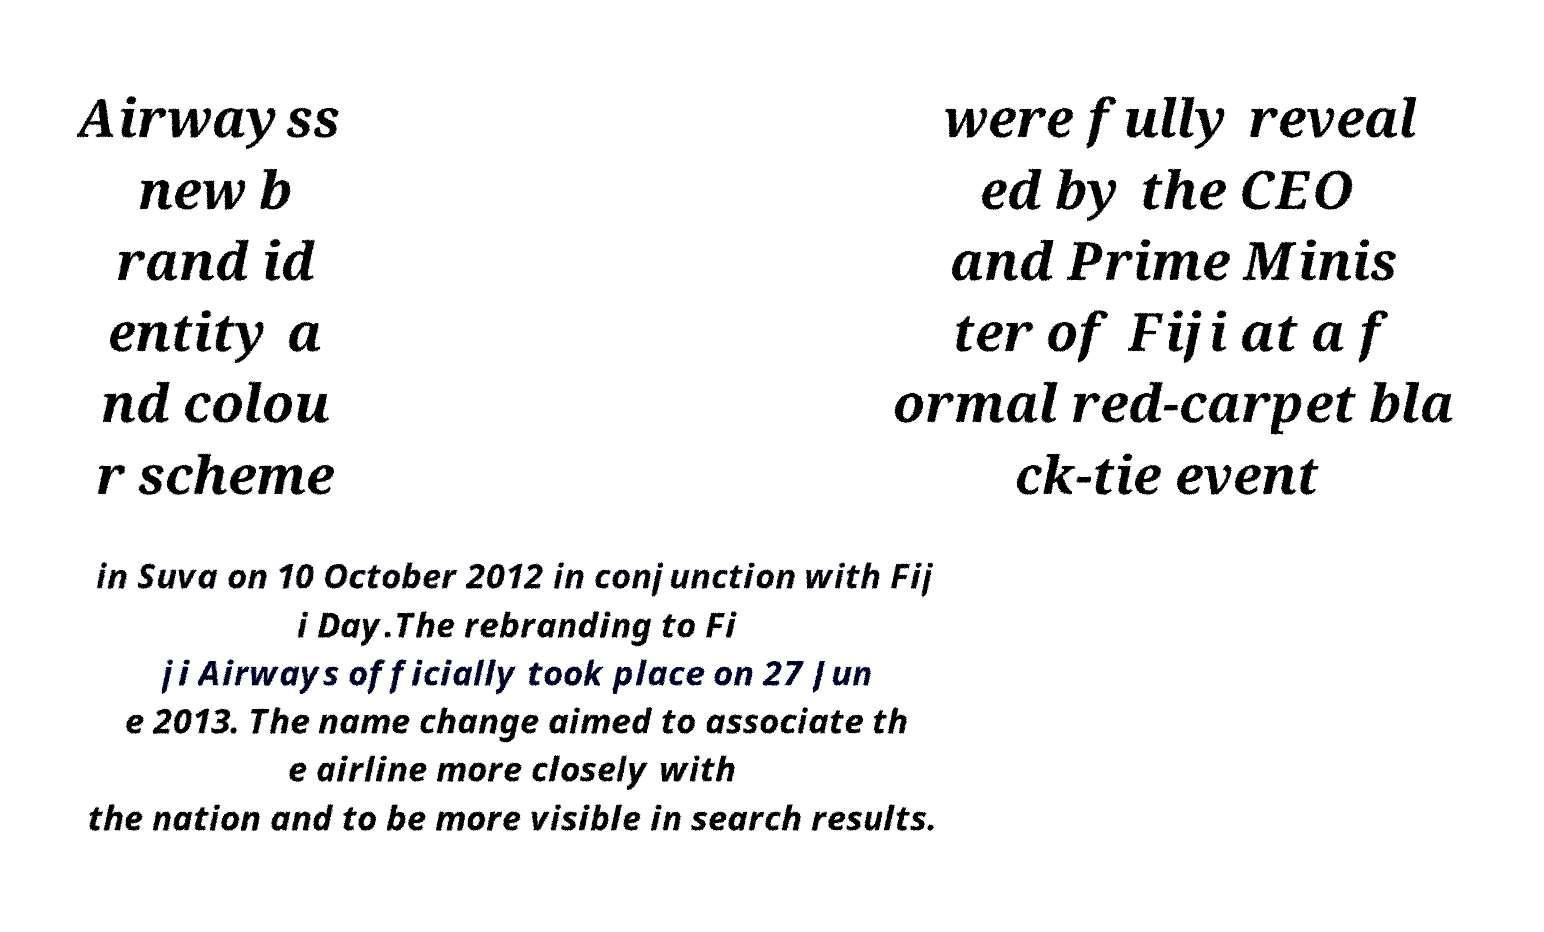What messages or text are displayed in this image? I need them in a readable, typed format. Airwayss new b rand id entity a nd colou r scheme were fully reveal ed by the CEO and Prime Minis ter of Fiji at a f ormal red-carpet bla ck-tie event in Suva on 10 October 2012 in conjunction with Fij i Day.The rebranding to Fi ji Airways officially took place on 27 Jun e 2013. The name change aimed to associate th e airline more closely with the nation and to be more visible in search results. 